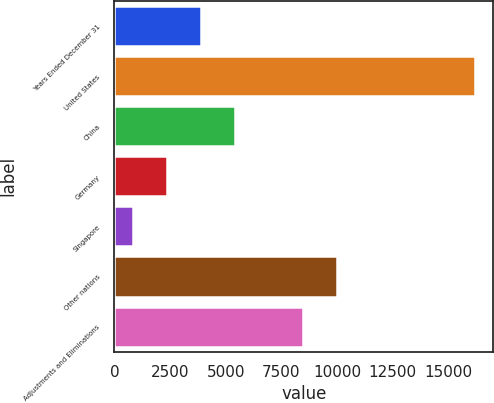Convert chart to OTSL. <chart><loc_0><loc_0><loc_500><loc_500><bar_chart><fcel>Years Ended December 31<fcel>United States<fcel>China<fcel>Germany<fcel>Singapore<fcel>Other nations<fcel>Adjustments and Eliminations<nl><fcel>3895.2<fcel>16216<fcel>5435.3<fcel>2355.1<fcel>815<fcel>10012.1<fcel>8472<nl></chart> 